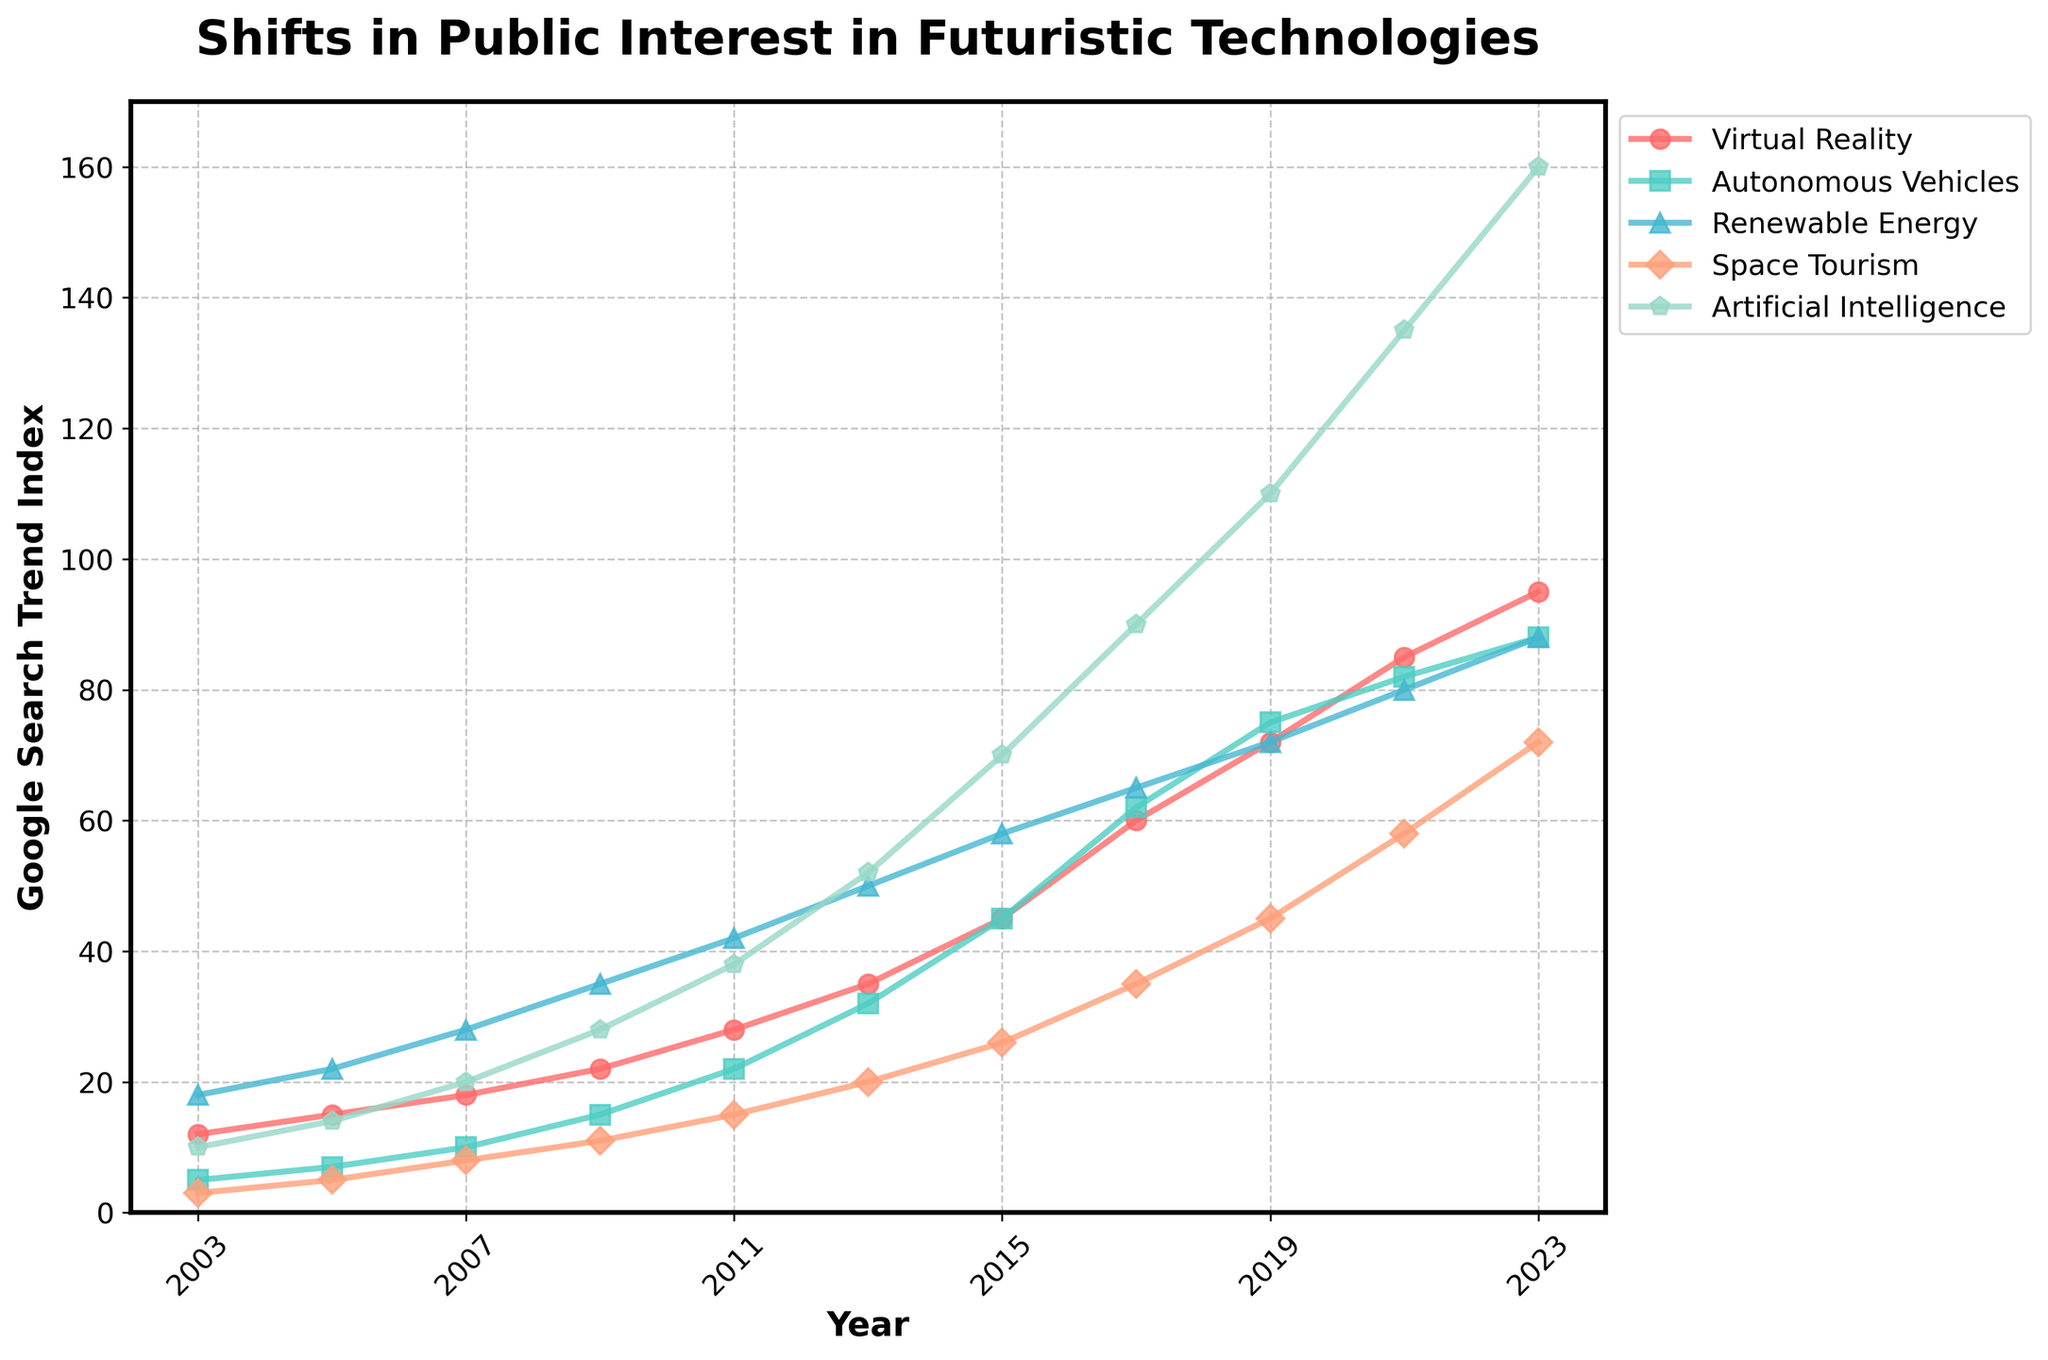Which futuristic technology saw the highest increase in public interest between 2003 and 2023? To determine this, look at the difference in the trend index for each technology between 2003 and 2023. Virtual Reality increased from 12 to 95 (+83), Autonomous Vehicles from 5 to 88 (+83), Renewable Energy from 18 to 88 (+70), Space Tourism from 3 to 72 (+69), and Artificial Intelligence from 10 to 160 (+150). Artificial Intelligence saw the highest increase of +150.
Answer: Artificial Intelligence Which technology had the lowest public interest in 2003 and how did it change over the years? In 2003, Space Tourism had the lowest interest with an index of 3. The trend increased steadily over the years, reaching 72 by 2023. This indicates a continuous rise in public interest in Space Tourism over the two decades.
Answer: Space Tourism increased from 3 to 72 Between 2011 and 2017, which technology saw the most rapid increase in public interest and what was the percentage increase? Calculate the percentage increase for each technology from 2011 to 2017: Virtual Reality (from 28 to 60, a 114.3% increase), Autonomous Vehicles (from 22 to 62, a 181.8% increase), Renewable Energy (from 42 to 65, a 54.8% increase), Space Tourism (from 15 to 35, a 133.3% increase), Artificial Intelligence (from 38 to 90, a 136.8% increase). The most rapid increase was in Autonomous Vehicles, with 181.8%.
Answer: Autonomous Vehicles, 181.8% In 2021, which technology had the highest Google search trend index and how much higher was it compared to the second highest? In 2021, Artificial Intelligence had the highest trend index at 135. The second highest was Autonomous Vehicles at 82. The difference is 135 - 82 = 53.
Answer: Artificial Intelligence, 53 higher Which two technologies had nearly equal public interest in 2023 and what was the index value? In 2023, both Virtual Reality and Renewable Energy had a similar trend index value of 88.
Answer: Virtual Reality and Renewable Energy, 88 How did the interest in Space Tourism change from 2015 to 2023? Look at the trend index for Space Tourism in 2015 (26) and in 2023 (72). The change is 72 - 26 = 46, showing a significant increase in public interest over these years.
Answer: Increased by 46 What was the average Google search trend index for Renewable Energy between 2009 and 2019? Find the trend indices for Renewable Energy in 2009 (35), 2011 (42), 2013 (50), 2015 (58), 2017 (65), and 2019 (72). The average is calculated as (35+42+50+58+65+72)/6 = 53.67, roughly 54.
Answer: 54 